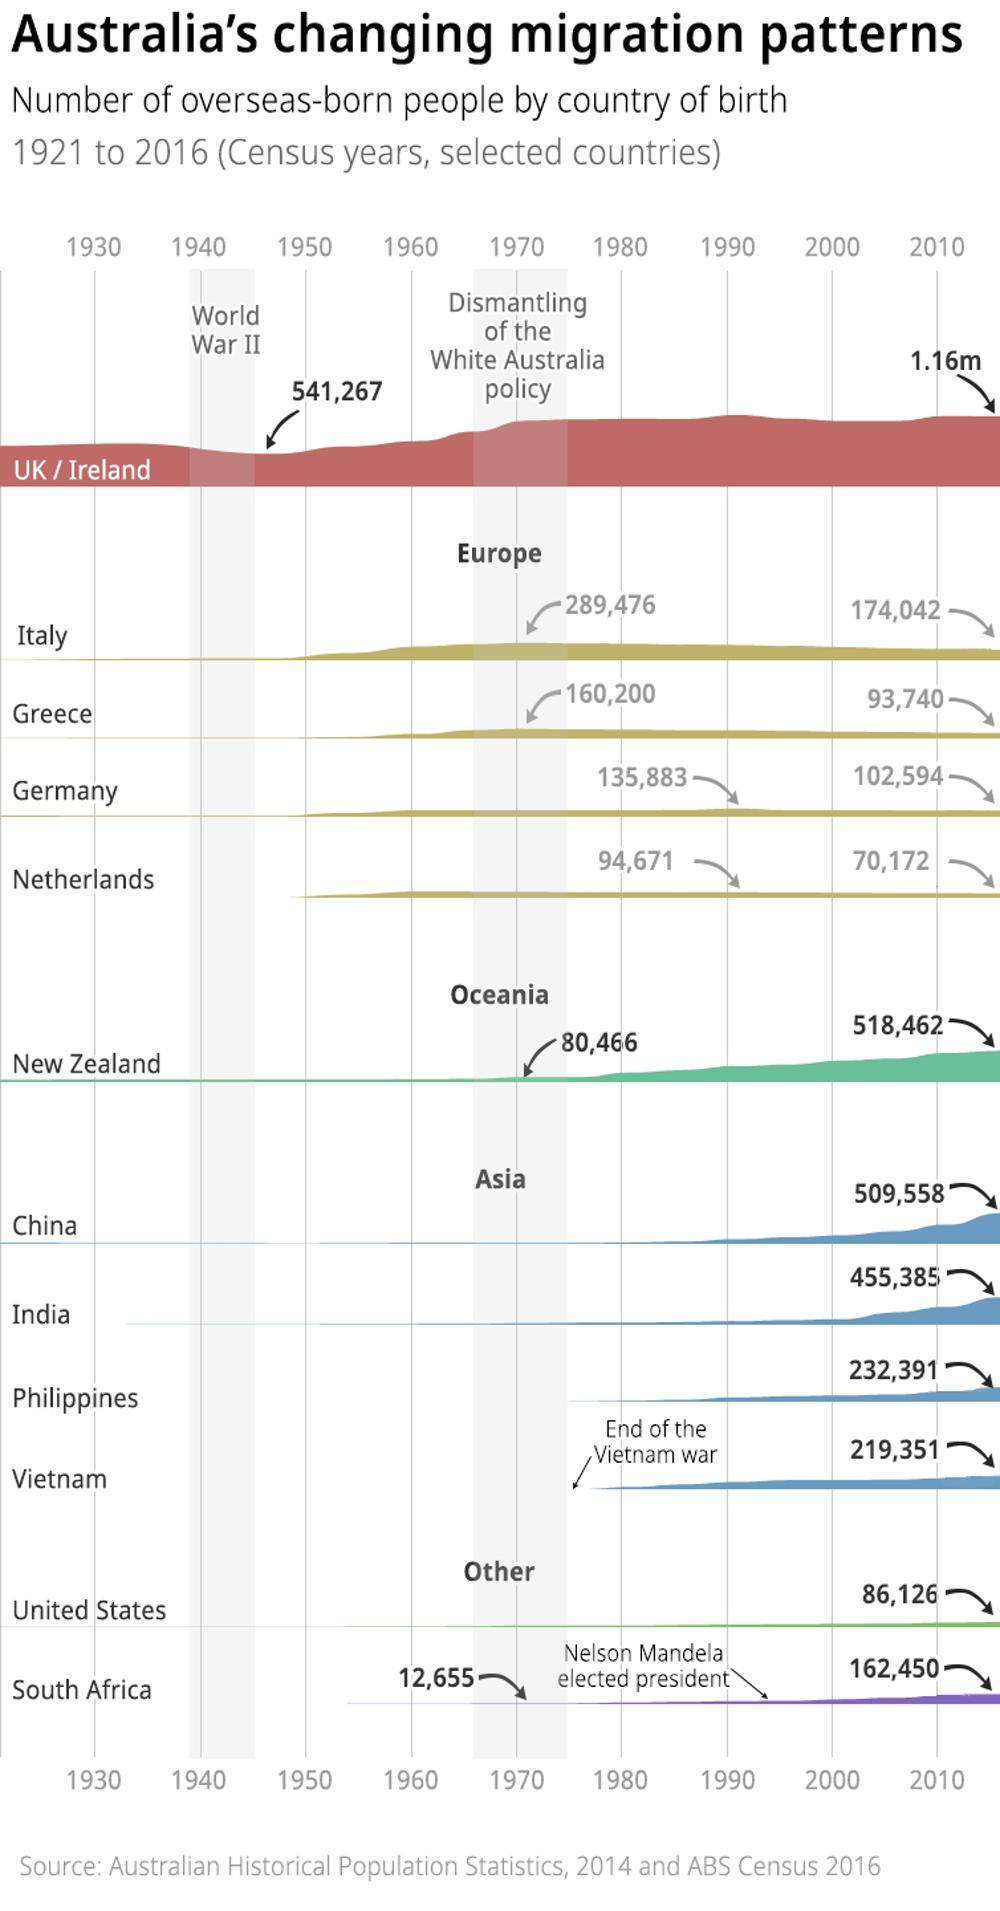List a handful of essential elements in this visual. The Philippines has the second lowest population among the countries in Asia. The dismantling of the White Australia policy did not occur until 30 years after World War II. After 1970, Italy, a country in Europe, has shown the highest decline in numbers. 